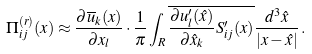Convert formula to latex. <formula><loc_0><loc_0><loc_500><loc_500>\Pi ^ { ( r ) } _ { i j } ( x ) \approx \frac { \partial \overline { u } _ { k } ( x ) } { \partial { x } _ { l } } \cdot \frac { 1 } { \pi } \int _ { R } \overline { \frac { \partial u ^ { \prime } _ { l } ( \hat { x } ) } { \partial \hat { x } _ { k } } S ^ { \prime } _ { i j } ( x ) } \frac { d ^ { 3 } \hat { x } } { | x - \hat { x } | } \, .</formula> 